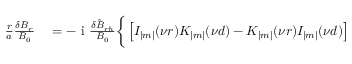<formula> <loc_0><loc_0><loc_500><loc_500>\begin{array} { r } { \begin{array} { r l } { \frac { r } { a } \frac { \delta B _ { r } } { B _ { 0 } } } & = - i \frac { \delta \hat { B } _ { r h } } { B _ { 0 } } \Big \{ \left [ I _ { | m | } ( \nu r ) K _ { | m | } ( \nu d ) - K _ { | m | } ( \nu r ) I _ { | m | } ( \nu d ) \right ] } \end{array} } \end{array}</formula> 